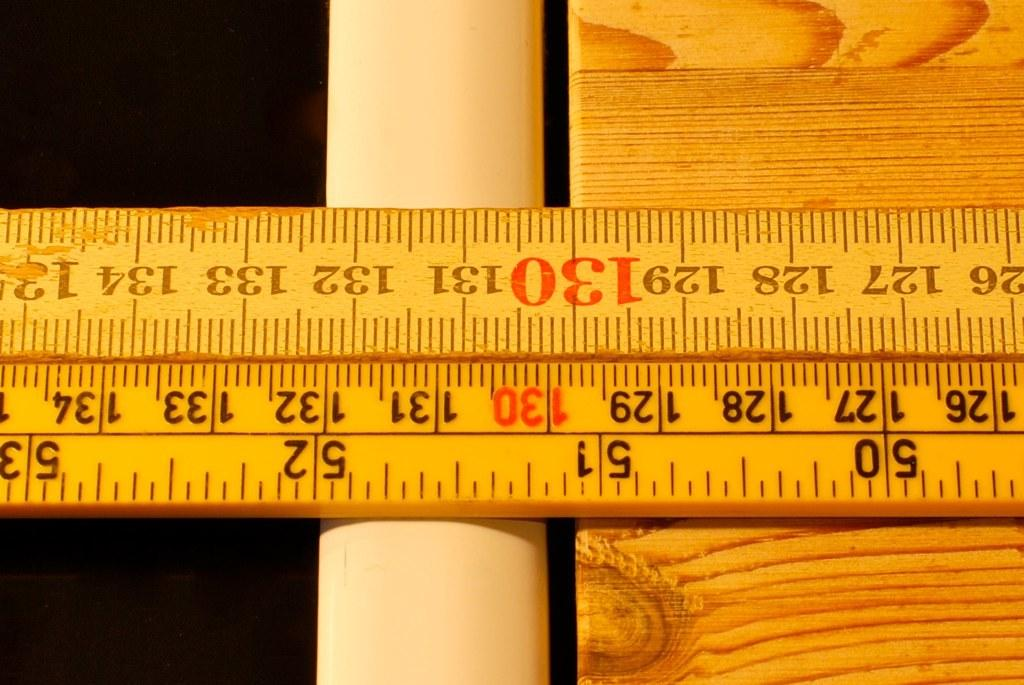<image>
Offer a succinct explanation of the picture presented. A wooden ruler has the number 130 in red on either side. 